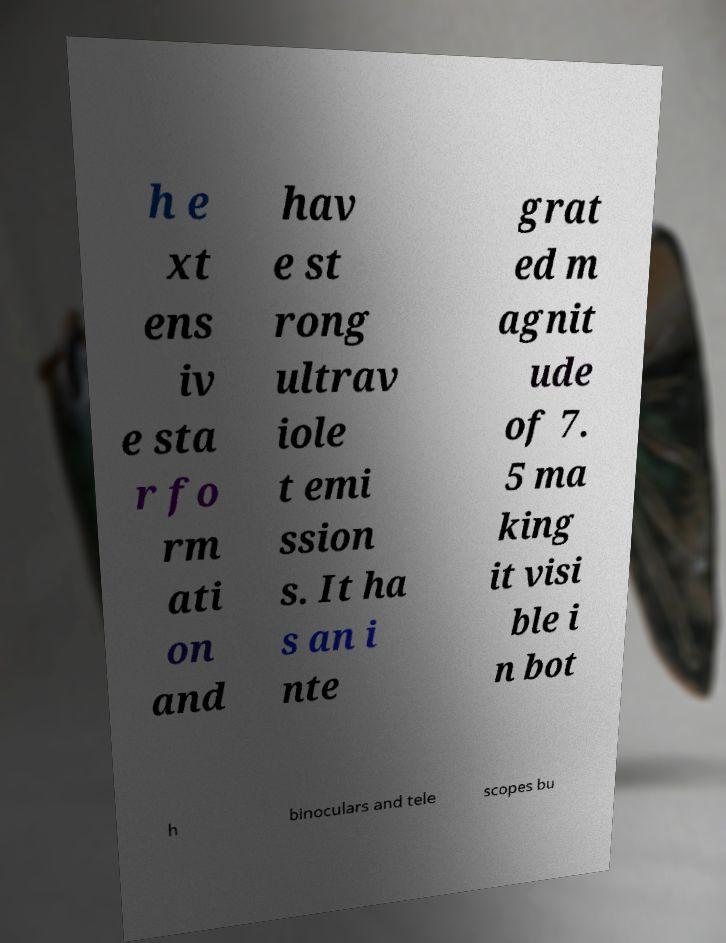Could you assist in decoding the text presented in this image and type it out clearly? h e xt ens iv e sta r fo rm ati on and hav e st rong ultrav iole t emi ssion s. It ha s an i nte grat ed m agnit ude of 7. 5 ma king it visi ble i n bot h binoculars and tele scopes bu 